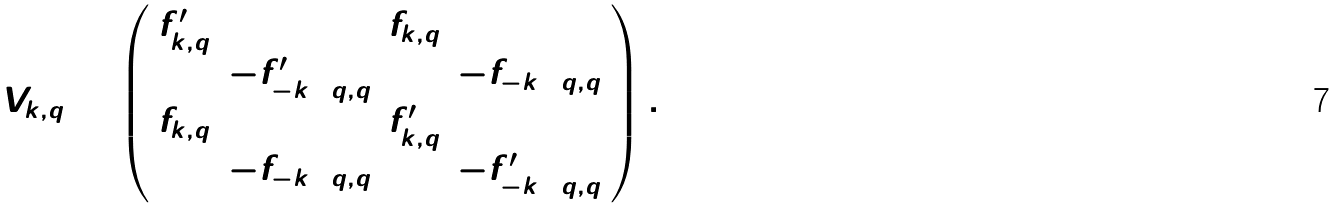Convert formula to latex. <formula><loc_0><loc_0><loc_500><loc_500>\hat { V } _ { k , q } = \left ( \begin{array} { c c c c } f ^ { \prime } _ { k , q } & 0 & f _ { k , q } & 0 \\ 0 & - f ^ { \prime } _ { - k + q , q } & 0 & - f _ { - k + q , q } \\ f _ { k , q } & 0 & f ^ { \prime } _ { k , q } & 0 \\ 0 & - f _ { - k + q , q } & 0 & - f ^ { \prime } _ { - k + q , q } \end{array} \right ) .</formula> 